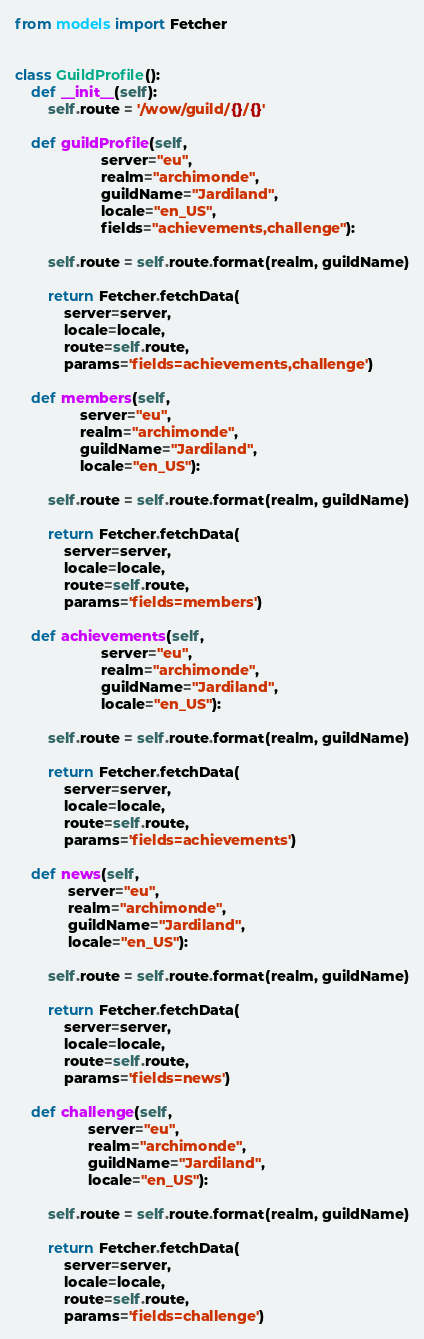<code> <loc_0><loc_0><loc_500><loc_500><_Python_>from models import Fetcher


class GuildProfile():
    def __init__(self):
        self.route = '/wow/guild/{}/{}'

    def guildProfile(self,
                     server="eu",
                     realm="archimonde",
                     guildName="Jardiland",
                     locale="en_US",
                     fields="achievements,challenge"):

        self.route = self.route.format(realm, guildName)

        return Fetcher.fetchData(
            server=server,
            locale=locale,
            route=self.route,
            params='fields=achievements,challenge')

    def members(self,
                server="eu",
                realm="archimonde",
                guildName="Jardiland",
                locale="en_US"):

        self.route = self.route.format(realm, guildName)

        return Fetcher.fetchData(
            server=server,
            locale=locale,
            route=self.route,
            params='fields=members')

    def achievements(self,
                     server="eu",
                     realm="archimonde",
                     guildName="Jardiland",
                     locale="en_US"):

        self.route = self.route.format(realm, guildName)

        return Fetcher.fetchData(
            server=server,
            locale=locale,
            route=self.route,
            params='fields=achievements')

    def news(self,
             server="eu",
             realm="archimonde",
             guildName="Jardiland",
             locale="en_US"):

        self.route = self.route.format(realm, guildName)

        return Fetcher.fetchData(
            server=server,
            locale=locale,
            route=self.route,
            params='fields=news')

    def challenge(self,
                  server="eu",
                  realm="archimonde",
                  guildName="Jardiland",
                  locale="en_US"):

        self.route = self.route.format(realm, guildName)

        return Fetcher.fetchData(
            server=server,
            locale=locale,
            route=self.route,
            params='fields=challenge')
</code> 